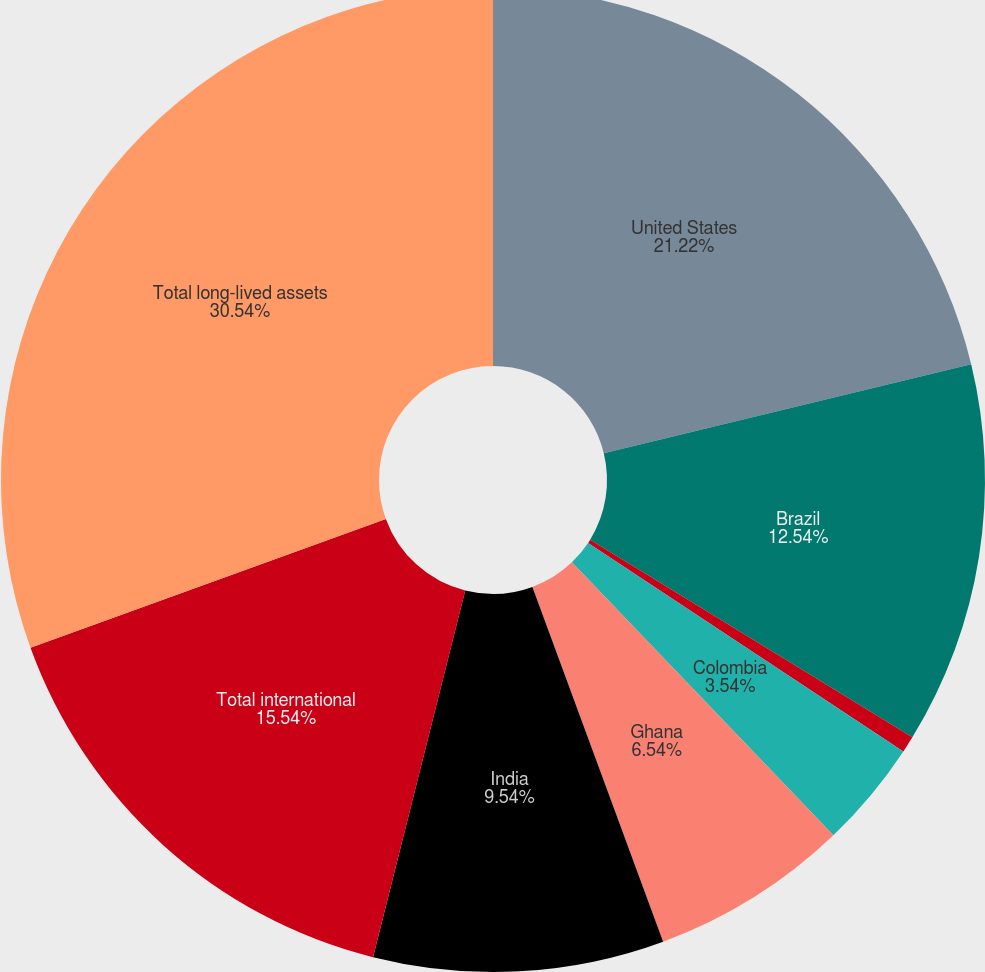<chart> <loc_0><loc_0><loc_500><loc_500><pie_chart><fcel>United States<fcel>Brazil<fcel>Chile<fcel>Colombia<fcel>Ghana<fcel>India<fcel>Total international<fcel>Total long-lived assets<nl><fcel>21.22%<fcel>12.54%<fcel>0.54%<fcel>3.54%<fcel>6.54%<fcel>9.54%<fcel>15.54%<fcel>30.54%<nl></chart> 